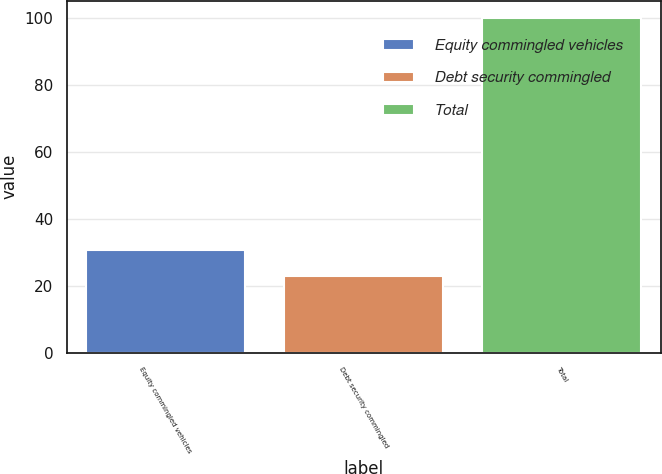Convert chart. <chart><loc_0><loc_0><loc_500><loc_500><bar_chart><fcel>Equity commingled vehicles<fcel>Debt security commingled<fcel>Total<nl><fcel>30.7<fcel>23<fcel>100<nl></chart> 